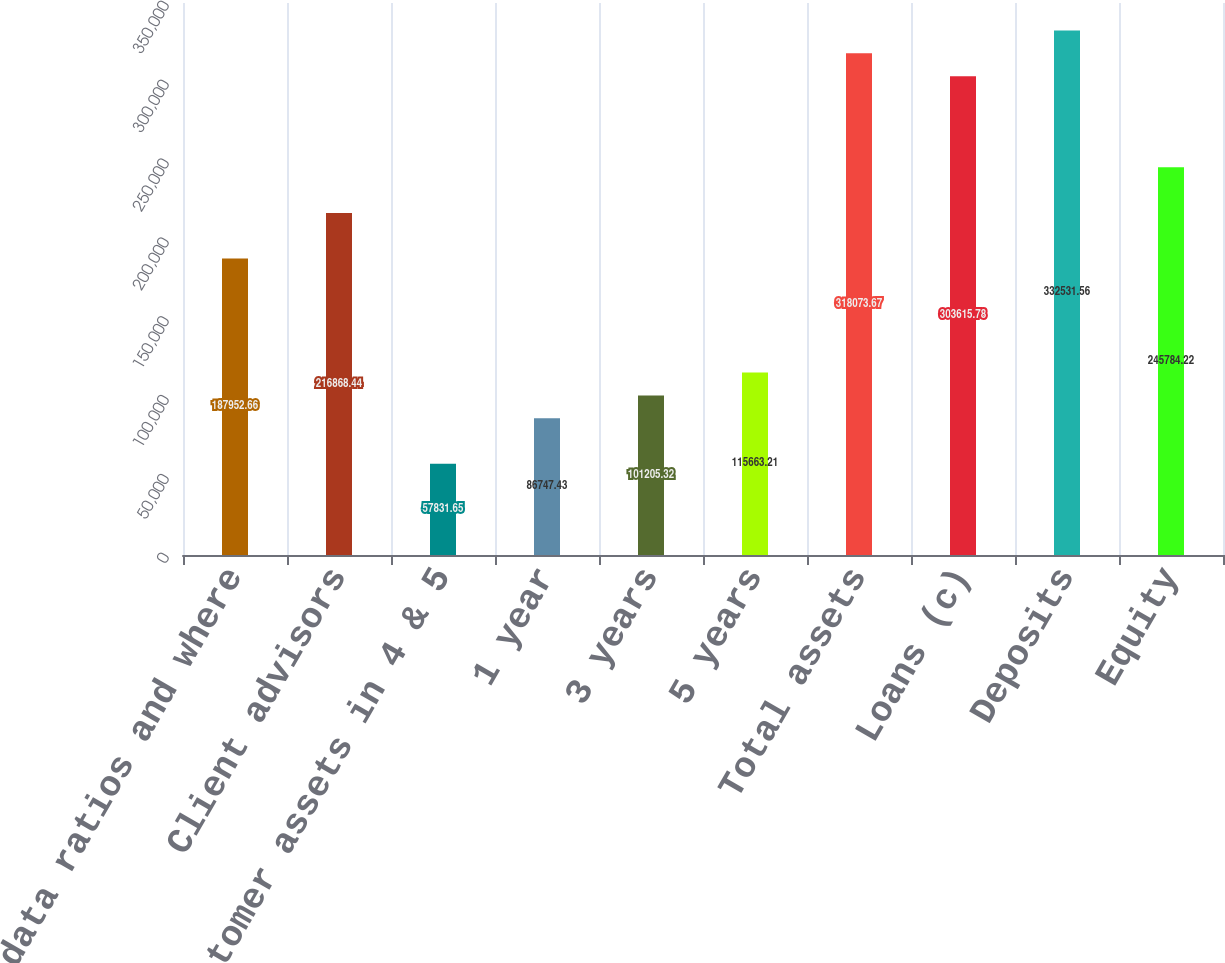<chart> <loc_0><loc_0><loc_500><loc_500><bar_chart><fcel>data ratios and where<fcel>Client advisors<fcel>of customer assets in 4 & 5<fcel>1 year<fcel>3 years<fcel>5 years<fcel>Total assets<fcel>Loans (c)<fcel>Deposits<fcel>Equity<nl><fcel>187953<fcel>216868<fcel>57831.7<fcel>86747.4<fcel>101205<fcel>115663<fcel>318074<fcel>303616<fcel>332532<fcel>245784<nl></chart> 